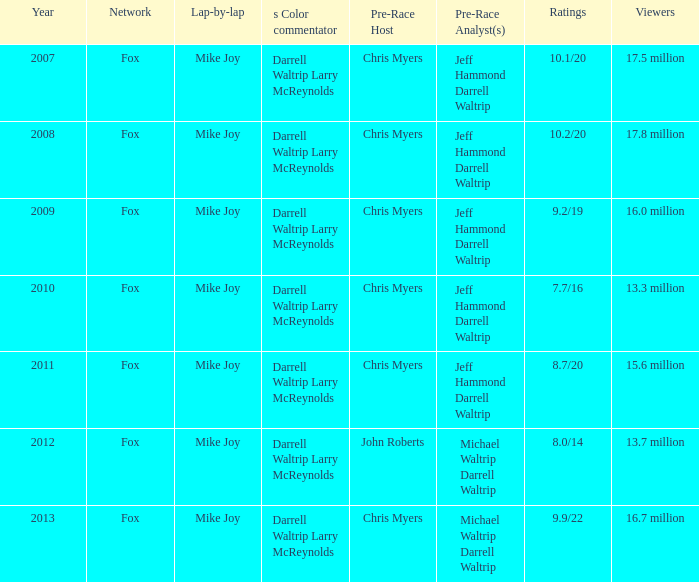Which Year is the lowest when the Viewers are 13.7 million? 2012.0. 